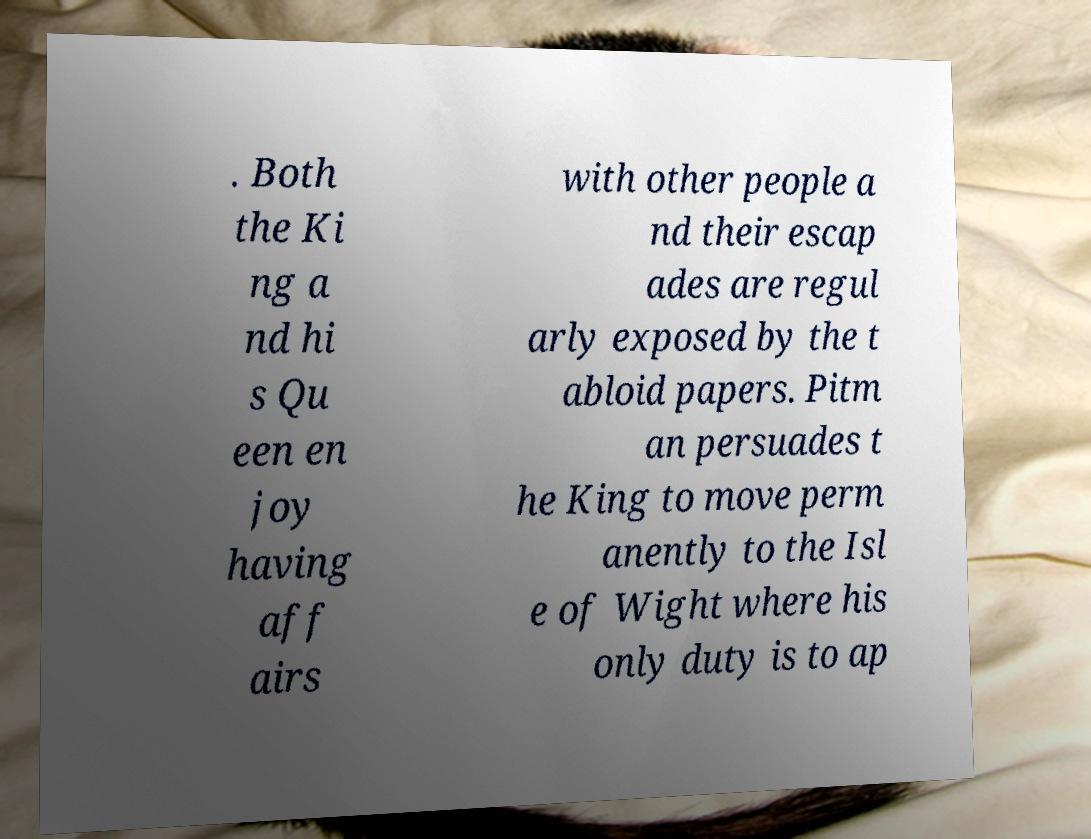Please identify and transcribe the text found in this image. . Both the Ki ng a nd hi s Qu een en joy having aff airs with other people a nd their escap ades are regul arly exposed by the t abloid papers. Pitm an persuades t he King to move perm anently to the Isl e of Wight where his only duty is to ap 